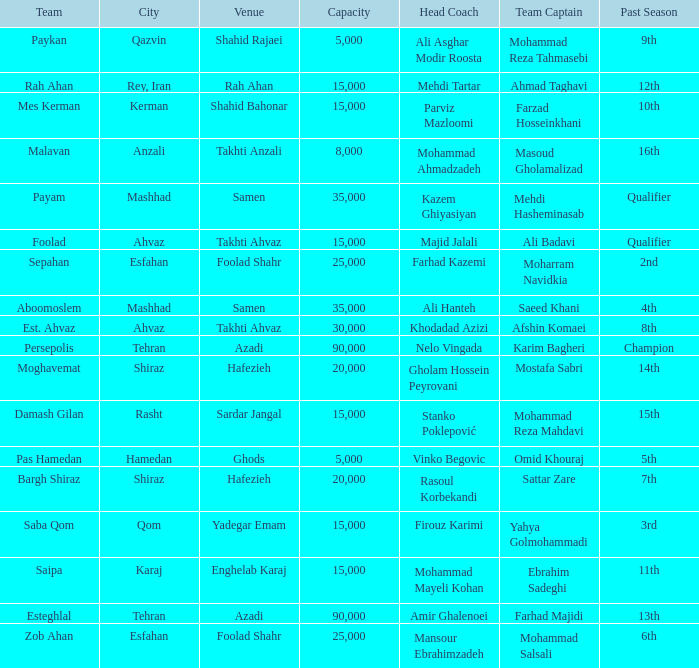What is the Capacity of the Venue of Head Coach Ali Asghar Modir Roosta? 5000.0. 